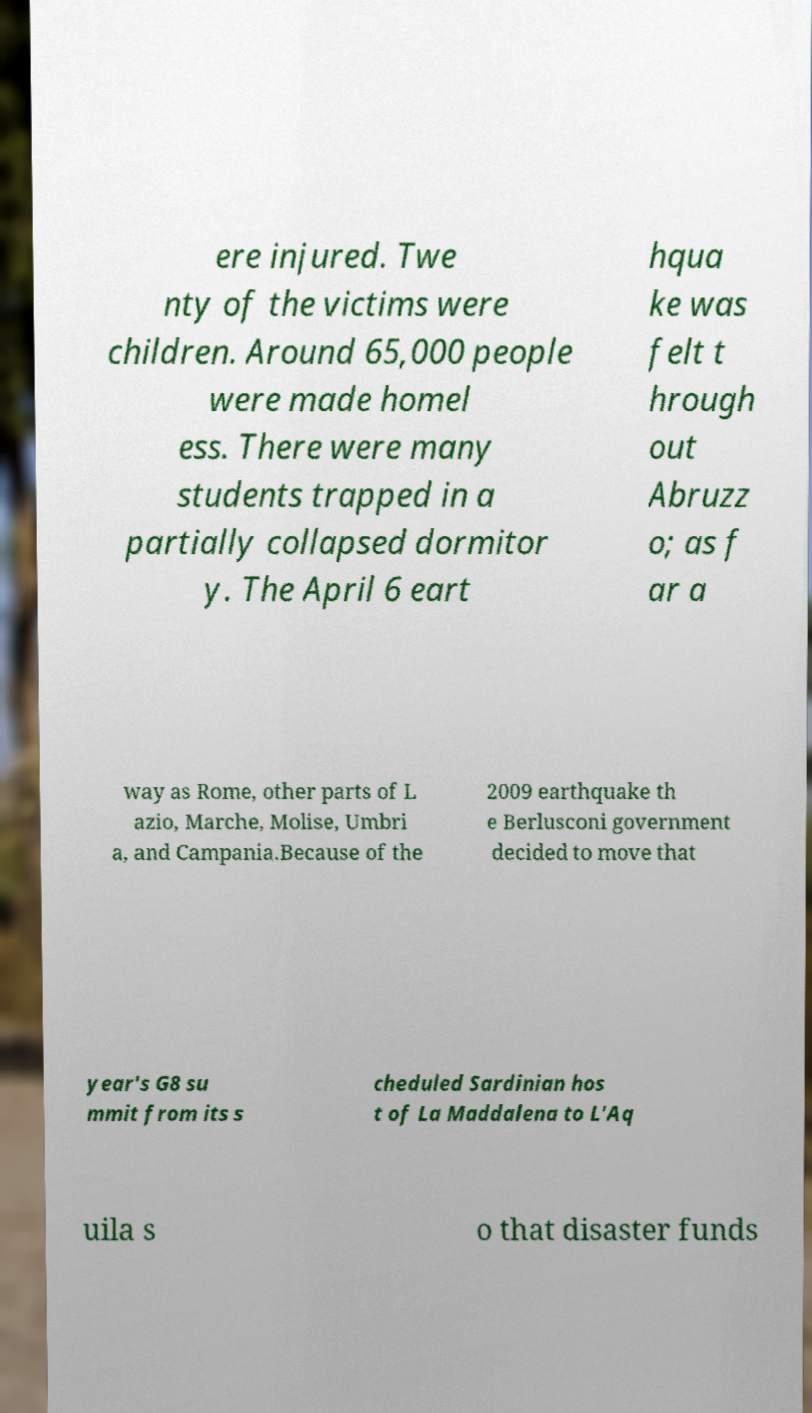Could you extract and type out the text from this image? ere injured. Twe nty of the victims were children. Around 65,000 people were made homel ess. There were many students trapped in a partially collapsed dormitor y. The April 6 eart hqua ke was felt t hrough out Abruzz o; as f ar a way as Rome, other parts of L azio, Marche, Molise, Umbri a, and Campania.Because of the 2009 earthquake th e Berlusconi government decided to move that year's G8 su mmit from its s cheduled Sardinian hos t of La Maddalena to L'Aq uila s o that disaster funds 